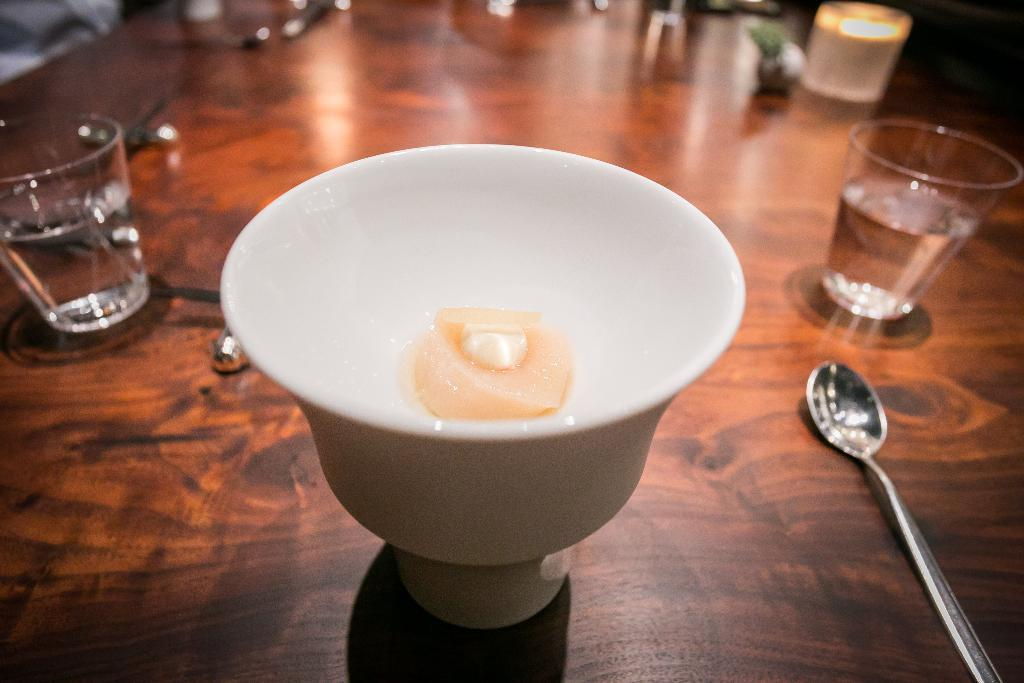What is the main object in the image? There is a bowl in the image. What utensil is present in the image? There is a spoon in the image. What other object can be seen in the image? There is a glass in the image. Where are these objects located? All objects are placed on a table. What type of club is being used in the image? There is no club present in the image; it only features a bowl, spoon, and glass on a table. 